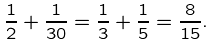Convert formula to latex. <formula><loc_0><loc_0><loc_500><loc_500>\frac { 1 } { 2 } + \frac { 1 } { 3 0 } = \frac { 1 } { 3 } + \frac { 1 } { 5 } = \frac { 8 } { 1 5 } .</formula> 